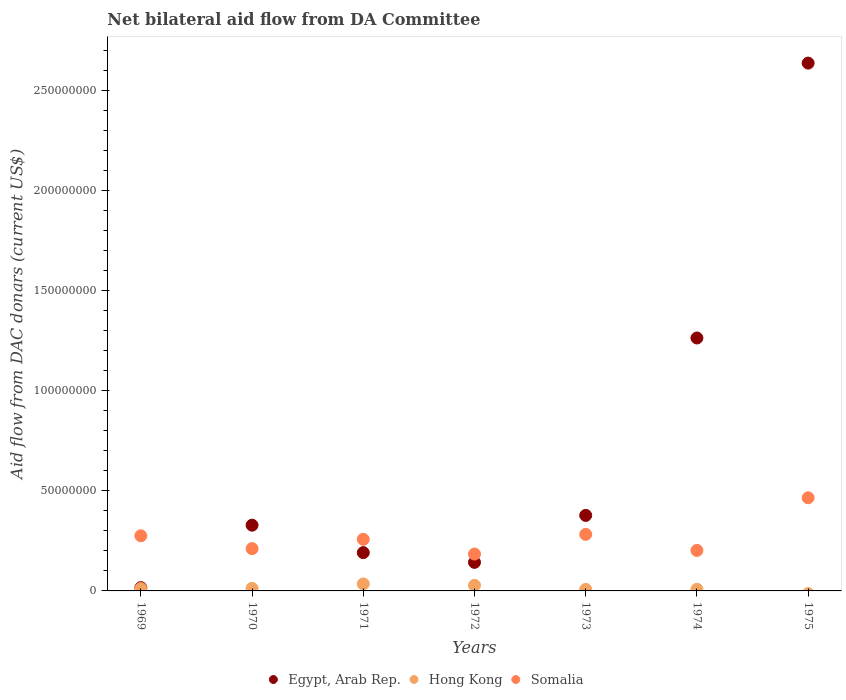How many different coloured dotlines are there?
Provide a short and direct response. 3. Is the number of dotlines equal to the number of legend labels?
Make the answer very short. No. Across all years, what is the maximum aid flow in in Hong Kong?
Give a very brief answer. 3.51e+06. In which year was the aid flow in in Egypt, Arab Rep. maximum?
Offer a terse response. 1975. What is the total aid flow in in Egypt, Arab Rep. in the graph?
Your answer should be very brief. 4.95e+08. What is the difference between the aid flow in in Egypt, Arab Rep. in 1969 and that in 1971?
Provide a short and direct response. -1.75e+07. What is the difference between the aid flow in in Egypt, Arab Rep. in 1973 and the aid flow in in Hong Kong in 1971?
Make the answer very short. 3.42e+07. What is the average aid flow in in Somalia per year?
Offer a terse response. 2.68e+07. In the year 1973, what is the difference between the aid flow in in Somalia and aid flow in in Hong Kong?
Offer a very short reply. 2.75e+07. What is the ratio of the aid flow in in Hong Kong in 1969 to that in 1970?
Provide a short and direct response. 0.91. Is the aid flow in in Egypt, Arab Rep. in 1969 less than that in 1975?
Make the answer very short. Yes. What is the difference between the highest and the second highest aid flow in in Somalia?
Your answer should be very brief. 1.83e+07. What is the difference between the highest and the lowest aid flow in in Hong Kong?
Give a very brief answer. 3.51e+06. In how many years, is the aid flow in in Somalia greater than the average aid flow in in Somalia taken over all years?
Provide a short and direct response. 3. Is it the case that in every year, the sum of the aid flow in in Somalia and aid flow in in Hong Kong  is greater than the aid flow in in Egypt, Arab Rep.?
Offer a terse response. No. Does the aid flow in in Egypt, Arab Rep. monotonically increase over the years?
Offer a very short reply. No. Is the aid flow in in Hong Kong strictly greater than the aid flow in in Egypt, Arab Rep. over the years?
Ensure brevity in your answer.  No. Is the aid flow in in Egypt, Arab Rep. strictly less than the aid flow in in Hong Kong over the years?
Offer a very short reply. No. How many dotlines are there?
Offer a terse response. 3. What is the difference between two consecutive major ticks on the Y-axis?
Ensure brevity in your answer.  5.00e+07. Are the values on the major ticks of Y-axis written in scientific E-notation?
Offer a terse response. No. How many legend labels are there?
Provide a succinct answer. 3. How are the legend labels stacked?
Ensure brevity in your answer.  Horizontal. What is the title of the graph?
Keep it short and to the point. Net bilateral aid flow from DA Committee. Does "Afghanistan" appear as one of the legend labels in the graph?
Provide a short and direct response. No. What is the label or title of the X-axis?
Offer a very short reply. Years. What is the label or title of the Y-axis?
Make the answer very short. Aid flow from DAC donars (current US$). What is the Aid flow from DAC donars (current US$) of Egypt, Arab Rep. in 1969?
Provide a short and direct response. 1.63e+06. What is the Aid flow from DAC donars (current US$) of Hong Kong in 1969?
Your response must be concise. 1.17e+06. What is the Aid flow from DAC donars (current US$) of Somalia in 1969?
Make the answer very short. 2.75e+07. What is the Aid flow from DAC donars (current US$) in Egypt, Arab Rep. in 1970?
Keep it short and to the point. 3.28e+07. What is the Aid flow from DAC donars (current US$) in Hong Kong in 1970?
Make the answer very short. 1.29e+06. What is the Aid flow from DAC donars (current US$) in Somalia in 1970?
Provide a short and direct response. 2.11e+07. What is the Aid flow from DAC donars (current US$) of Egypt, Arab Rep. in 1971?
Offer a very short reply. 1.91e+07. What is the Aid flow from DAC donars (current US$) in Hong Kong in 1971?
Ensure brevity in your answer.  3.51e+06. What is the Aid flow from DAC donars (current US$) in Somalia in 1971?
Offer a terse response. 2.58e+07. What is the Aid flow from DAC donars (current US$) of Egypt, Arab Rep. in 1972?
Keep it short and to the point. 1.43e+07. What is the Aid flow from DAC donars (current US$) in Hong Kong in 1972?
Your answer should be compact. 2.79e+06. What is the Aid flow from DAC donars (current US$) of Somalia in 1972?
Offer a very short reply. 1.84e+07. What is the Aid flow from DAC donars (current US$) of Egypt, Arab Rep. in 1973?
Give a very brief answer. 3.77e+07. What is the Aid flow from DAC donars (current US$) of Hong Kong in 1973?
Ensure brevity in your answer.  7.80e+05. What is the Aid flow from DAC donars (current US$) of Somalia in 1973?
Make the answer very short. 2.82e+07. What is the Aid flow from DAC donars (current US$) of Egypt, Arab Rep. in 1974?
Your answer should be very brief. 1.26e+08. What is the Aid flow from DAC donars (current US$) of Hong Kong in 1974?
Your answer should be very brief. 8.20e+05. What is the Aid flow from DAC donars (current US$) of Somalia in 1974?
Your answer should be compact. 2.02e+07. What is the Aid flow from DAC donars (current US$) in Egypt, Arab Rep. in 1975?
Provide a short and direct response. 2.64e+08. What is the Aid flow from DAC donars (current US$) in Hong Kong in 1975?
Give a very brief answer. 0. What is the Aid flow from DAC donars (current US$) in Somalia in 1975?
Keep it short and to the point. 4.65e+07. Across all years, what is the maximum Aid flow from DAC donars (current US$) of Egypt, Arab Rep.?
Your response must be concise. 2.64e+08. Across all years, what is the maximum Aid flow from DAC donars (current US$) in Hong Kong?
Ensure brevity in your answer.  3.51e+06. Across all years, what is the maximum Aid flow from DAC donars (current US$) in Somalia?
Ensure brevity in your answer.  4.65e+07. Across all years, what is the minimum Aid flow from DAC donars (current US$) of Egypt, Arab Rep.?
Your answer should be compact. 1.63e+06. Across all years, what is the minimum Aid flow from DAC donars (current US$) of Hong Kong?
Provide a short and direct response. 0. Across all years, what is the minimum Aid flow from DAC donars (current US$) of Somalia?
Provide a succinct answer. 1.84e+07. What is the total Aid flow from DAC donars (current US$) in Egypt, Arab Rep. in the graph?
Offer a terse response. 4.95e+08. What is the total Aid flow from DAC donars (current US$) in Hong Kong in the graph?
Provide a short and direct response. 1.04e+07. What is the total Aid flow from DAC donars (current US$) of Somalia in the graph?
Your answer should be compact. 1.88e+08. What is the difference between the Aid flow from DAC donars (current US$) in Egypt, Arab Rep. in 1969 and that in 1970?
Offer a terse response. -3.12e+07. What is the difference between the Aid flow from DAC donars (current US$) in Hong Kong in 1969 and that in 1970?
Offer a very short reply. -1.20e+05. What is the difference between the Aid flow from DAC donars (current US$) of Somalia in 1969 and that in 1970?
Offer a very short reply. 6.43e+06. What is the difference between the Aid flow from DAC donars (current US$) in Egypt, Arab Rep. in 1969 and that in 1971?
Offer a terse response. -1.75e+07. What is the difference between the Aid flow from DAC donars (current US$) in Hong Kong in 1969 and that in 1971?
Your answer should be compact. -2.34e+06. What is the difference between the Aid flow from DAC donars (current US$) in Somalia in 1969 and that in 1971?
Your answer should be very brief. 1.77e+06. What is the difference between the Aid flow from DAC donars (current US$) in Egypt, Arab Rep. in 1969 and that in 1972?
Provide a short and direct response. -1.26e+07. What is the difference between the Aid flow from DAC donars (current US$) of Hong Kong in 1969 and that in 1972?
Keep it short and to the point. -1.62e+06. What is the difference between the Aid flow from DAC donars (current US$) of Somalia in 1969 and that in 1972?
Your answer should be very brief. 9.13e+06. What is the difference between the Aid flow from DAC donars (current US$) of Egypt, Arab Rep. in 1969 and that in 1973?
Offer a terse response. -3.61e+07. What is the difference between the Aid flow from DAC donars (current US$) of Somalia in 1969 and that in 1973?
Give a very brief answer. -7.10e+05. What is the difference between the Aid flow from DAC donars (current US$) of Egypt, Arab Rep. in 1969 and that in 1974?
Offer a very short reply. -1.25e+08. What is the difference between the Aid flow from DAC donars (current US$) in Hong Kong in 1969 and that in 1974?
Keep it short and to the point. 3.50e+05. What is the difference between the Aid flow from DAC donars (current US$) in Somalia in 1969 and that in 1974?
Provide a succinct answer. 7.31e+06. What is the difference between the Aid flow from DAC donars (current US$) in Egypt, Arab Rep. in 1969 and that in 1975?
Give a very brief answer. -2.62e+08. What is the difference between the Aid flow from DAC donars (current US$) in Somalia in 1969 and that in 1975?
Keep it short and to the point. -1.90e+07. What is the difference between the Aid flow from DAC donars (current US$) of Egypt, Arab Rep. in 1970 and that in 1971?
Provide a short and direct response. 1.37e+07. What is the difference between the Aid flow from DAC donars (current US$) of Hong Kong in 1970 and that in 1971?
Your answer should be very brief. -2.22e+06. What is the difference between the Aid flow from DAC donars (current US$) of Somalia in 1970 and that in 1971?
Offer a very short reply. -4.66e+06. What is the difference between the Aid flow from DAC donars (current US$) of Egypt, Arab Rep. in 1970 and that in 1972?
Keep it short and to the point. 1.86e+07. What is the difference between the Aid flow from DAC donars (current US$) of Hong Kong in 1970 and that in 1972?
Provide a succinct answer. -1.50e+06. What is the difference between the Aid flow from DAC donars (current US$) in Somalia in 1970 and that in 1972?
Offer a terse response. 2.70e+06. What is the difference between the Aid flow from DAC donars (current US$) in Egypt, Arab Rep. in 1970 and that in 1973?
Your response must be concise. -4.89e+06. What is the difference between the Aid flow from DAC donars (current US$) of Hong Kong in 1970 and that in 1973?
Your response must be concise. 5.10e+05. What is the difference between the Aid flow from DAC donars (current US$) in Somalia in 1970 and that in 1973?
Give a very brief answer. -7.14e+06. What is the difference between the Aid flow from DAC donars (current US$) of Egypt, Arab Rep. in 1970 and that in 1974?
Your response must be concise. -9.35e+07. What is the difference between the Aid flow from DAC donars (current US$) in Somalia in 1970 and that in 1974?
Provide a short and direct response. 8.80e+05. What is the difference between the Aid flow from DAC donars (current US$) of Egypt, Arab Rep. in 1970 and that in 1975?
Ensure brevity in your answer.  -2.31e+08. What is the difference between the Aid flow from DAC donars (current US$) in Somalia in 1970 and that in 1975?
Keep it short and to the point. -2.54e+07. What is the difference between the Aid flow from DAC donars (current US$) in Egypt, Arab Rep. in 1971 and that in 1972?
Provide a short and direct response. 4.86e+06. What is the difference between the Aid flow from DAC donars (current US$) of Hong Kong in 1971 and that in 1972?
Provide a succinct answer. 7.20e+05. What is the difference between the Aid flow from DAC donars (current US$) of Somalia in 1971 and that in 1972?
Offer a terse response. 7.36e+06. What is the difference between the Aid flow from DAC donars (current US$) of Egypt, Arab Rep. in 1971 and that in 1973?
Give a very brief answer. -1.86e+07. What is the difference between the Aid flow from DAC donars (current US$) of Hong Kong in 1971 and that in 1973?
Your answer should be very brief. 2.73e+06. What is the difference between the Aid flow from DAC donars (current US$) in Somalia in 1971 and that in 1973?
Ensure brevity in your answer.  -2.48e+06. What is the difference between the Aid flow from DAC donars (current US$) in Egypt, Arab Rep. in 1971 and that in 1974?
Offer a very short reply. -1.07e+08. What is the difference between the Aid flow from DAC donars (current US$) in Hong Kong in 1971 and that in 1974?
Offer a terse response. 2.69e+06. What is the difference between the Aid flow from DAC donars (current US$) of Somalia in 1971 and that in 1974?
Give a very brief answer. 5.54e+06. What is the difference between the Aid flow from DAC donars (current US$) of Egypt, Arab Rep. in 1971 and that in 1975?
Your answer should be very brief. -2.44e+08. What is the difference between the Aid flow from DAC donars (current US$) in Somalia in 1971 and that in 1975?
Ensure brevity in your answer.  -2.07e+07. What is the difference between the Aid flow from DAC donars (current US$) of Egypt, Arab Rep. in 1972 and that in 1973?
Make the answer very short. -2.35e+07. What is the difference between the Aid flow from DAC donars (current US$) of Hong Kong in 1972 and that in 1973?
Provide a succinct answer. 2.01e+06. What is the difference between the Aid flow from DAC donars (current US$) of Somalia in 1972 and that in 1973?
Provide a short and direct response. -9.84e+06. What is the difference between the Aid flow from DAC donars (current US$) of Egypt, Arab Rep. in 1972 and that in 1974?
Give a very brief answer. -1.12e+08. What is the difference between the Aid flow from DAC donars (current US$) in Hong Kong in 1972 and that in 1974?
Your answer should be very brief. 1.97e+06. What is the difference between the Aid flow from DAC donars (current US$) in Somalia in 1972 and that in 1974?
Provide a short and direct response. -1.82e+06. What is the difference between the Aid flow from DAC donars (current US$) of Egypt, Arab Rep. in 1972 and that in 1975?
Give a very brief answer. -2.49e+08. What is the difference between the Aid flow from DAC donars (current US$) in Somalia in 1972 and that in 1975?
Your answer should be very brief. -2.81e+07. What is the difference between the Aid flow from DAC donars (current US$) of Egypt, Arab Rep. in 1973 and that in 1974?
Give a very brief answer. -8.86e+07. What is the difference between the Aid flow from DAC donars (current US$) of Somalia in 1973 and that in 1974?
Your answer should be compact. 8.02e+06. What is the difference between the Aid flow from DAC donars (current US$) in Egypt, Arab Rep. in 1973 and that in 1975?
Keep it short and to the point. -2.26e+08. What is the difference between the Aid flow from DAC donars (current US$) in Somalia in 1973 and that in 1975?
Your answer should be compact. -1.83e+07. What is the difference between the Aid flow from DAC donars (current US$) in Egypt, Arab Rep. in 1974 and that in 1975?
Keep it short and to the point. -1.37e+08. What is the difference between the Aid flow from DAC donars (current US$) in Somalia in 1974 and that in 1975?
Provide a succinct answer. -2.63e+07. What is the difference between the Aid flow from DAC donars (current US$) of Egypt, Arab Rep. in 1969 and the Aid flow from DAC donars (current US$) of Hong Kong in 1970?
Offer a terse response. 3.40e+05. What is the difference between the Aid flow from DAC donars (current US$) in Egypt, Arab Rep. in 1969 and the Aid flow from DAC donars (current US$) in Somalia in 1970?
Your answer should be very brief. -1.95e+07. What is the difference between the Aid flow from DAC donars (current US$) in Hong Kong in 1969 and the Aid flow from DAC donars (current US$) in Somalia in 1970?
Your answer should be very brief. -1.99e+07. What is the difference between the Aid flow from DAC donars (current US$) of Egypt, Arab Rep. in 1969 and the Aid flow from DAC donars (current US$) of Hong Kong in 1971?
Make the answer very short. -1.88e+06. What is the difference between the Aid flow from DAC donars (current US$) of Egypt, Arab Rep. in 1969 and the Aid flow from DAC donars (current US$) of Somalia in 1971?
Make the answer very short. -2.41e+07. What is the difference between the Aid flow from DAC donars (current US$) in Hong Kong in 1969 and the Aid flow from DAC donars (current US$) in Somalia in 1971?
Offer a very short reply. -2.46e+07. What is the difference between the Aid flow from DAC donars (current US$) in Egypt, Arab Rep. in 1969 and the Aid flow from DAC donars (current US$) in Hong Kong in 1972?
Make the answer very short. -1.16e+06. What is the difference between the Aid flow from DAC donars (current US$) in Egypt, Arab Rep. in 1969 and the Aid flow from DAC donars (current US$) in Somalia in 1972?
Offer a very short reply. -1.68e+07. What is the difference between the Aid flow from DAC donars (current US$) in Hong Kong in 1969 and the Aid flow from DAC donars (current US$) in Somalia in 1972?
Give a very brief answer. -1.72e+07. What is the difference between the Aid flow from DAC donars (current US$) in Egypt, Arab Rep. in 1969 and the Aid flow from DAC donars (current US$) in Hong Kong in 1973?
Offer a very short reply. 8.50e+05. What is the difference between the Aid flow from DAC donars (current US$) of Egypt, Arab Rep. in 1969 and the Aid flow from DAC donars (current US$) of Somalia in 1973?
Provide a succinct answer. -2.66e+07. What is the difference between the Aid flow from DAC donars (current US$) in Hong Kong in 1969 and the Aid flow from DAC donars (current US$) in Somalia in 1973?
Your response must be concise. -2.71e+07. What is the difference between the Aid flow from DAC donars (current US$) in Egypt, Arab Rep. in 1969 and the Aid flow from DAC donars (current US$) in Hong Kong in 1974?
Give a very brief answer. 8.10e+05. What is the difference between the Aid flow from DAC donars (current US$) of Egypt, Arab Rep. in 1969 and the Aid flow from DAC donars (current US$) of Somalia in 1974?
Your response must be concise. -1.86e+07. What is the difference between the Aid flow from DAC donars (current US$) of Hong Kong in 1969 and the Aid flow from DAC donars (current US$) of Somalia in 1974?
Provide a succinct answer. -1.91e+07. What is the difference between the Aid flow from DAC donars (current US$) of Egypt, Arab Rep. in 1969 and the Aid flow from DAC donars (current US$) of Somalia in 1975?
Keep it short and to the point. -4.49e+07. What is the difference between the Aid flow from DAC donars (current US$) of Hong Kong in 1969 and the Aid flow from DAC donars (current US$) of Somalia in 1975?
Make the answer very short. -4.53e+07. What is the difference between the Aid flow from DAC donars (current US$) in Egypt, Arab Rep. in 1970 and the Aid flow from DAC donars (current US$) in Hong Kong in 1971?
Make the answer very short. 2.93e+07. What is the difference between the Aid flow from DAC donars (current US$) in Egypt, Arab Rep. in 1970 and the Aid flow from DAC donars (current US$) in Somalia in 1971?
Ensure brevity in your answer.  7.06e+06. What is the difference between the Aid flow from DAC donars (current US$) of Hong Kong in 1970 and the Aid flow from DAC donars (current US$) of Somalia in 1971?
Give a very brief answer. -2.45e+07. What is the difference between the Aid flow from DAC donars (current US$) of Egypt, Arab Rep. in 1970 and the Aid flow from DAC donars (current US$) of Hong Kong in 1972?
Your answer should be compact. 3.00e+07. What is the difference between the Aid flow from DAC donars (current US$) of Egypt, Arab Rep. in 1970 and the Aid flow from DAC donars (current US$) of Somalia in 1972?
Provide a short and direct response. 1.44e+07. What is the difference between the Aid flow from DAC donars (current US$) in Hong Kong in 1970 and the Aid flow from DAC donars (current US$) in Somalia in 1972?
Keep it short and to the point. -1.71e+07. What is the difference between the Aid flow from DAC donars (current US$) of Egypt, Arab Rep. in 1970 and the Aid flow from DAC donars (current US$) of Hong Kong in 1973?
Keep it short and to the point. 3.20e+07. What is the difference between the Aid flow from DAC donars (current US$) of Egypt, Arab Rep. in 1970 and the Aid flow from DAC donars (current US$) of Somalia in 1973?
Provide a succinct answer. 4.58e+06. What is the difference between the Aid flow from DAC donars (current US$) in Hong Kong in 1970 and the Aid flow from DAC donars (current US$) in Somalia in 1973?
Provide a succinct answer. -2.70e+07. What is the difference between the Aid flow from DAC donars (current US$) of Egypt, Arab Rep. in 1970 and the Aid flow from DAC donars (current US$) of Hong Kong in 1974?
Provide a short and direct response. 3.20e+07. What is the difference between the Aid flow from DAC donars (current US$) of Egypt, Arab Rep. in 1970 and the Aid flow from DAC donars (current US$) of Somalia in 1974?
Make the answer very short. 1.26e+07. What is the difference between the Aid flow from DAC donars (current US$) of Hong Kong in 1970 and the Aid flow from DAC donars (current US$) of Somalia in 1974?
Give a very brief answer. -1.89e+07. What is the difference between the Aid flow from DAC donars (current US$) of Egypt, Arab Rep. in 1970 and the Aid flow from DAC donars (current US$) of Somalia in 1975?
Offer a very short reply. -1.37e+07. What is the difference between the Aid flow from DAC donars (current US$) of Hong Kong in 1970 and the Aid flow from DAC donars (current US$) of Somalia in 1975?
Make the answer very short. -4.52e+07. What is the difference between the Aid flow from DAC donars (current US$) in Egypt, Arab Rep. in 1971 and the Aid flow from DAC donars (current US$) in Hong Kong in 1972?
Your response must be concise. 1.63e+07. What is the difference between the Aid flow from DAC donars (current US$) in Egypt, Arab Rep. in 1971 and the Aid flow from DAC donars (current US$) in Somalia in 1972?
Keep it short and to the point. 7.10e+05. What is the difference between the Aid flow from DAC donars (current US$) of Hong Kong in 1971 and the Aid flow from DAC donars (current US$) of Somalia in 1972?
Provide a succinct answer. -1.49e+07. What is the difference between the Aid flow from DAC donars (current US$) in Egypt, Arab Rep. in 1971 and the Aid flow from DAC donars (current US$) in Hong Kong in 1973?
Your answer should be compact. 1.83e+07. What is the difference between the Aid flow from DAC donars (current US$) of Egypt, Arab Rep. in 1971 and the Aid flow from DAC donars (current US$) of Somalia in 1973?
Give a very brief answer. -9.13e+06. What is the difference between the Aid flow from DAC donars (current US$) of Hong Kong in 1971 and the Aid flow from DAC donars (current US$) of Somalia in 1973?
Ensure brevity in your answer.  -2.47e+07. What is the difference between the Aid flow from DAC donars (current US$) in Egypt, Arab Rep. in 1971 and the Aid flow from DAC donars (current US$) in Hong Kong in 1974?
Provide a short and direct response. 1.83e+07. What is the difference between the Aid flow from DAC donars (current US$) in Egypt, Arab Rep. in 1971 and the Aid flow from DAC donars (current US$) in Somalia in 1974?
Ensure brevity in your answer.  -1.11e+06. What is the difference between the Aid flow from DAC donars (current US$) in Hong Kong in 1971 and the Aid flow from DAC donars (current US$) in Somalia in 1974?
Make the answer very short. -1.67e+07. What is the difference between the Aid flow from DAC donars (current US$) in Egypt, Arab Rep. in 1971 and the Aid flow from DAC donars (current US$) in Somalia in 1975?
Your answer should be compact. -2.74e+07. What is the difference between the Aid flow from DAC donars (current US$) of Hong Kong in 1971 and the Aid flow from DAC donars (current US$) of Somalia in 1975?
Provide a short and direct response. -4.30e+07. What is the difference between the Aid flow from DAC donars (current US$) of Egypt, Arab Rep. in 1972 and the Aid flow from DAC donars (current US$) of Hong Kong in 1973?
Your answer should be compact. 1.35e+07. What is the difference between the Aid flow from DAC donars (current US$) in Egypt, Arab Rep. in 1972 and the Aid flow from DAC donars (current US$) in Somalia in 1973?
Offer a very short reply. -1.40e+07. What is the difference between the Aid flow from DAC donars (current US$) in Hong Kong in 1972 and the Aid flow from DAC donars (current US$) in Somalia in 1973?
Make the answer very short. -2.55e+07. What is the difference between the Aid flow from DAC donars (current US$) in Egypt, Arab Rep. in 1972 and the Aid flow from DAC donars (current US$) in Hong Kong in 1974?
Your response must be concise. 1.34e+07. What is the difference between the Aid flow from DAC donars (current US$) of Egypt, Arab Rep. in 1972 and the Aid flow from DAC donars (current US$) of Somalia in 1974?
Provide a succinct answer. -5.97e+06. What is the difference between the Aid flow from DAC donars (current US$) in Hong Kong in 1972 and the Aid flow from DAC donars (current US$) in Somalia in 1974?
Keep it short and to the point. -1.74e+07. What is the difference between the Aid flow from DAC donars (current US$) of Egypt, Arab Rep. in 1972 and the Aid flow from DAC donars (current US$) of Somalia in 1975?
Keep it short and to the point. -3.22e+07. What is the difference between the Aid flow from DAC donars (current US$) in Hong Kong in 1972 and the Aid flow from DAC donars (current US$) in Somalia in 1975?
Provide a succinct answer. -4.37e+07. What is the difference between the Aid flow from DAC donars (current US$) in Egypt, Arab Rep. in 1973 and the Aid flow from DAC donars (current US$) in Hong Kong in 1974?
Keep it short and to the point. 3.69e+07. What is the difference between the Aid flow from DAC donars (current US$) of Egypt, Arab Rep. in 1973 and the Aid flow from DAC donars (current US$) of Somalia in 1974?
Offer a very short reply. 1.75e+07. What is the difference between the Aid flow from DAC donars (current US$) of Hong Kong in 1973 and the Aid flow from DAC donars (current US$) of Somalia in 1974?
Make the answer very short. -1.94e+07. What is the difference between the Aid flow from DAC donars (current US$) in Egypt, Arab Rep. in 1973 and the Aid flow from DAC donars (current US$) in Somalia in 1975?
Make the answer very short. -8.79e+06. What is the difference between the Aid flow from DAC donars (current US$) of Hong Kong in 1973 and the Aid flow from DAC donars (current US$) of Somalia in 1975?
Your response must be concise. -4.57e+07. What is the difference between the Aid flow from DAC donars (current US$) of Egypt, Arab Rep. in 1974 and the Aid flow from DAC donars (current US$) of Somalia in 1975?
Make the answer very short. 7.98e+07. What is the difference between the Aid flow from DAC donars (current US$) of Hong Kong in 1974 and the Aid flow from DAC donars (current US$) of Somalia in 1975?
Give a very brief answer. -4.57e+07. What is the average Aid flow from DAC donars (current US$) in Egypt, Arab Rep. per year?
Keep it short and to the point. 7.08e+07. What is the average Aid flow from DAC donars (current US$) of Hong Kong per year?
Make the answer very short. 1.48e+06. What is the average Aid flow from DAC donars (current US$) in Somalia per year?
Your answer should be compact. 2.68e+07. In the year 1969, what is the difference between the Aid flow from DAC donars (current US$) in Egypt, Arab Rep. and Aid flow from DAC donars (current US$) in Somalia?
Provide a short and direct response. -2.59e+07. In the year 1969, what is the difference between the Aid flow from DAC donars (current US$) in Hong Kong and Aid flow from DAC donars (current US$) in Somalia?
Your answer should be very brief. -2.64e+07. In the year 1970, what is the difference between the Aid flow from DAC donars (current US$) in Egypt, Arab Rep. and Aid flow from DAC donars (current US$) in Hong Kong?
Provide a succinct answer. 3.15e+07. In the year 1970, what is the difference between the Aid flow from DAC donars (current US$) in Egypt, Arab Rep. and Aid flow from DAC donars (current US$) in Somalia?
Make the answer very short. 1.17e+07. In the year 1970, what is the difference between the Aid flow from DAC donars (current US$) of Hong Kong and Aid flow from DAC donars (current US$) of Somalia?
Offer a very short reply. -1.98e+07. In the year 1971, what is the difference between the Aid flow from DAC donars (current US$) of Egypt, Arab Rep. and Aid flow from DAC donars (current US$) of Hong Kong?
Give a very brief answer. 1.56e+07. In the year 1971, what is the difference between the Aid flow from DAC donars (current US$) in Egypt, Arab Rep. and Aid flow from DAC donars (current US$) in Somalia?
Ensure brevity in your answer.  -6.65e+06. In the year 1971, what is the difference between the Aid flow from DAC donars (current US$) in Hong Kong and Aid flow from DAC donars (current US$) in Somalia?
Ensure brevity in your answer.  -2.23e+07. In the year 1972, what is the difference between the Aid flow from DAC donars (current US$) of Egypt, Arab Rep. and Aid flow from DAC donars (current US$) of Hong Kong?
Offer a terse response. 1.15e+07. In the year 1972, what is the difference between the Aid flow from DAC donars (current US$) in Egypt, Arab Rep. and Aid flow from DAC donars (current US$) in Somalia?
Give a very brief answer. -4.15e+06. In the year 1972, what is the difference between the Aid flow from DAC donars (current US$) in Hong Kong and Aid flow from DAC donars (current US$) in Somalia?
Your response must be concise. -1.56e+07. In the year 1973, what is the difference between the Aid flow from DAC donars (current US$) in Egypt, Arab Rep. and Aid flow from DAC donars (current US$) in Hong Kong?
Make the answer very short. 3.69e+07. In the year 1973, what is the difference between the Aid flow from DAC donars (current US$) of Egypt, Arab Rep. and Aid flow from DAC donars (current US$) of Somalia?
Offer a terse response. 9.47e+06. In the year 1973, what is the difference between the Aid flow from DAC donars (current US$) in Hong Kong and Aid flow from DAC donars (current US$) in Somalia?
Keep it short and to the point. -2.75e+07. In the year 1974, what is the difference between the Aid flow from DAC donars (current US$) in Egypt, Arab Rep. and Aid flow from DAC donars (current US$) in Hong Kong?
Your response must be concise. 1.26e+08. In the year 1974, what is the difference between the Aid flow from DAC donars (current US$) of Egypt, Arab Rep. and Aid flow from DAC donars (current US$) of Somalia?
Provide a succinct answer. 1.06e+08. In the year 1974, what is the difference between the Aid flow from DAC donars (current US$) of Hong Kong and Aid flow from DAC donars (current US$) of Somalia?
Give a very brief answer. -1.94e+07. In the year 1975, what is the difference between the Aid flow from DAC donars (current US$) of Egypt, Arab Rep. and Aid flow from DAC donars (current US$) of Somalia?
Provide a short and direct response. 2.17e+08. What is the ratio of the Aid flow from DAC donars (current US$) of Egypt, Arab Rep. in 1969 to that in 1970?
Provide a succinct answer. 0.05. What is the ratio of the Aid flow from DAC donars (current US$) in Hong Kong in 1969 to that in 1970?
Make the answer very short. 0.91. What is the ratio of the Aid flow from DAC donars (current US$) of Somalia in 1969 to that in 1970?
Keep it short and to the point. 1.3. What is the ratio of the Aid flow from DAC donars (current US$) of Egypt, Arab Rep. in 1969 to that in 1971?
Offer a very short reply. 0.09. What is the ratio of the Aid flow from DAC donars (current US$) in Somalia in 1969 to that in 1971?
Offer a very short reply. 1.07. What is the ratio of the Aid flow from DAC donars (current US$) of Egypt, Arab Rep. in 1969 to that in 1972?
Your answer should be compact. 0.11. What is the ratio of the Aid flow from DAC donars (current US$) of Hong Kong in 1969 to that in 1972?
Keep it short and to the point. 0.42. What is the ratio of the Aid flow from DAC donars (current US$) of Somalia in 1969 to that in 1972?
Ensure brevity in your answer.  1.5. What is the ratio of the Aid flow from DAC donars (current US$) in Egypt, Arab Rep. in 1969 to that in 1973?
Make the answer very short. 0.04. What is the ratio of the Aid flow from DAC donars (current US$) in Hong Kong in 1969 to that in 1973?
Give a very brief answer. 1.5. What is the ratio of the Aid flow from DAC donars (current US$) in Somalia in 1969 to that in 1973?
Your answer should be compact. 0.97. What is the ratio of the Aid flow from DAC donars (current US$) in Egypt, Arab Rep. in 1969 to that in 1974?
Your response must be concise. 0.01. What is the ratio of the Aid flow from DAC donars (current US$) in Hong Kong in 1969 to that in 1974?
Your response must be concise. 1.43. What is the ratio of the Aid flow from DAC donars (current US$) of Somalia in 1969 to that in 1974?
Your answer should be very brief. 1.36. What is the ratio of the Aid flow from DAC donars (current US$) of Egypt, Arab Rep. in 1969 to that in 1975?
Offer a very short reply. 0.01. What is the ratio of the Aid flow from DAC donars (current US$) in Somalia in 1969 to that in 1975?
Provide a short and direct response. 0.59. What is the ratio of the Aid flow from DAC donars (current US$) in Egypt, Arab Rep. in 1970 to that in 1971?
Offer a terse response. 1.72. What is the ratio of the Aid flow from DAC donars (current US$) in Hong Kong in 1970 to that in 1971?
Keep it short and to the point. 0.37. What is the ratio of the Aid flow from DAC donars (current US$) of Somalia in 1970 to that in 1971?
Make the answer very short. 0.82. What is the ratio of the Aid flow from DAC donars (current US$) in Egypt, Arab Rep. in 1970 to that in 1972?
Your response must be concise. 2.3. What is the ratio of the Aid flow from DAC donars (current US$) of Hong Kong in 1970 to that in 1972?
Give a very brief answer. 0.46. What is the ratio of the Aid flow from DAC donars (current US$) in Somalia in 1970 to that in 1972?
Keep it short and to the point. 1.15. What is the ratio of the Aid flow from DAC donars (current US$) of Egypt, Arab Rep. in 1970 to that in 1973?
Your answer should be compact. 0.87. What is the ratio of the Aid flow from DAC donars (current US$) in Hong Kong in 1970 to that in 1973?
Provide a short and direct response. 1.65. What is the ratio of the Aid flow from DAC donars (current US$) of Somalia in 1970 to that in 1973?
Your response must be concise. 0.75. What is the ratio of the Aid flow from DAC donars (current US$) of Egypt, Arab Rep. in 1970 to that in 1974?
Make the answer very short. 0.26. What is the ratio of the Aid flow from DAC donars (current US$) of Hong Kong in 1970 to that in 1974?
Keep it short and to the point. 1.57. What is the ratio of the Aid flow from DAC donars (current US$) of Somalia in 1970 to that in 1974?
Keep it short and to the point. 1.04. What is the ratio of the Aid flow from DAC donars (current US$) of Egypt, Arab Rep. in 1970 to that in 1975?
Provide a short and direct response. 0.12. What is the ratio of the Aid flow from DAC donars (current US$) in Somalia in 1970 to that in 1975?
Your answer should be very brief. 0.45. What is the ratio of the Aid flow from DAC donars (current US$) in Egypt, Arab Rep. in 1971 to that in 1972?
Your answer should be very brief. 1.34. What is the ratio of the Aid flow from DAC donars (current US$) of Hong Kong in 1971 to that in 1972?
Your response must be concise. 1.26. What is the ratio of the Aid flow from DAC donars (current US$) in Somalia in 1971 to that in 1972?
Offer a terse response. 1.4. What is the ratio of the Aid flow from DAC donars (current US$) of Egypt, Arab Rep. in 1971 to that in 1973?
Your response must be concise. 0.51. What is the ratio of the Aid flow from DAC donars (current US$) in Hong Kong in 1971 to that in 1973?
Provide a succinct answer. 4.5. What is the ratio of the Aid flow from DAC donars (current US$) of Somalia in 1971 to that in 1973?
Keep it short and to the point. 0.91. What is the ratio of the Aid flow from DAC donars (current US$) of Egypt, Arab Rep. in 1971 to that in 1974?
Provide a succinct answer. 0.15. What is the ratio of the Aid flow from DAC donars (current US$) of Hong Kong in 1971 to that in 1974?
Make the answer very short. 4.28. What is the ratio of the Aid flow from DAC donars (current US$) of Somalia in 1971 to that in 1974?
Offer a terse response. 1.27. What is the ratio of the Aid flow from DAC donars (current US$) in Egypt, Arab Rep. in 1971 to that in 1975?
Your answer should be very brief. 0.07. What is the ratio of the Aid flow from DAC donars (current US$) in Somalia in 1971 to that in 1975?
Make the answer very short. 0.55. What is the ratio of the Aid flow from DAC donars (current US$) in Egypt, Arab Rep. in 1972 to that in 1973?
Provide a succinct answer. 0.38. What is the ratio of the Aid flow from DAC donars (current US$) in Hong Kong in 1972 to that in 1973?
Your answer should be very brief. 3.58. What is the ratio of the Aid flow from DAC donars (current US$) in Somalia in 1972 to that in 1973?
Keep it short and to the point. 0.65. What is the ratio of the Aid flow from DAC donars (current US$) in Egypt, Arab Rep. in 1972 to that in 1974?
Give a very brief answer. 0.11. What is the ratio of the Aid flow from DAC donars (current US$) in Hong Kong in 1972 to that in 1974?
Provide a short and direct response. 3.4. What is the ratio of the Aid flow from DAC donars (current US$) of Somalia in 1972 to that in 1974?
Your response must be concise. 0.91. What is the ratio of the Aid flow from DAC donars (current US$) of Egypt, Arab Rep. in 1972 to that in 1975?
Ensure brevity in your answer.  0.05. What is the ratio of the Aid flow from DAC donars (current US$) in Somalia in 1972 to that in 1975?
Make the answer very short. 0.4. What is the ratio of the Aid flow from DAC donars (current US$) of Egypt, Arab Rep. in 1973 to that in 1974?
Your answer should be very brief. 0.3. What is the ratio of the Aid flow from DAC donars (current US$) of Hong Kong in 1973 to that in 1974?
Give a very brief answer. 0.95. What is the ratio of the Aid flow from DAC donars (current US$) of Somalia in 1973 to that in 1974?
Your answer should be very brief. 1.4. What is the ratio of the Aid flow from DAC donars (current US$) in Egypt, Arab Rep. in 1973 to that in 1975?
Your answer should be compact. 0.14. What is the ratio of the Aid flow from DAC donars (current US$) of Somalia in 1973 to that in 1975?
Give a very brief answer. 0.61. What is the ratio of the Aid flow from DAC donars (current US$) of Egypt, Arab Rep. in 1974 to that in 1975?
Make the answer very short. 0.48. What is the ratio of the Aid flow from DAC donars (current US$) of Somalia in 1974 to that in 1975?
Your answer should be compact. 0.43. What is the difference between the highest and the second highest Aid flow from DAC donars (current US$) in Egypt, Arab Rep.?
Ensure brevity in your answer.  1.37e+08. What is the difference between the highest and the second highest Aid flow from DAC donars (current US$) in Hong Kong?
Keep it short and to the point. 7.20e+05. What is the difference between the highest and the second highest Aid flow from DAC donars (current US$) of Somalia?
Your answer should be compact. 1.83e+07. What is the difference between the highest and the lowest Aid flow from DAC donars (current US$) in Egypt, Arab Rep.?
Your response must be concise. 2.62e+08. What is the difference between the highest and the lowest Aid flow from DAC donars (current US$) of Hong Kong?
Ensure brevity in your answer.  3.51e+06. What is the difference between the highest and the lowest Aid flow from DAC donars (current US$) of Somalia?
Provide a short and direct response. 2.81e+07. 